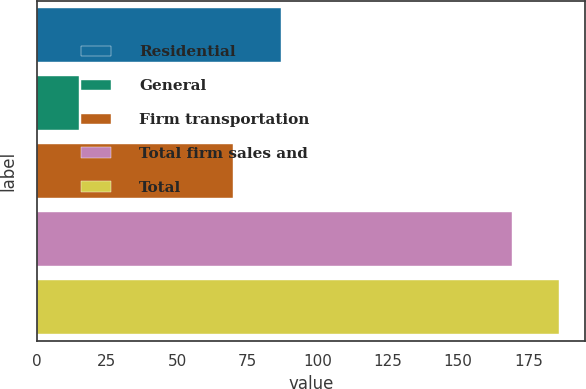Convert chart to OTSL. <chart><loc_0><loc_0><loc_500><loc_500><bar_chart><fcel>Residential<fcel>General<fcel>Firm transportation<fcel>Total firm sales and<fcel>Total<nl><fcel>86.9<fcel>15<fcel>70<fcel>169<fcel>185.9<nl></chart> 